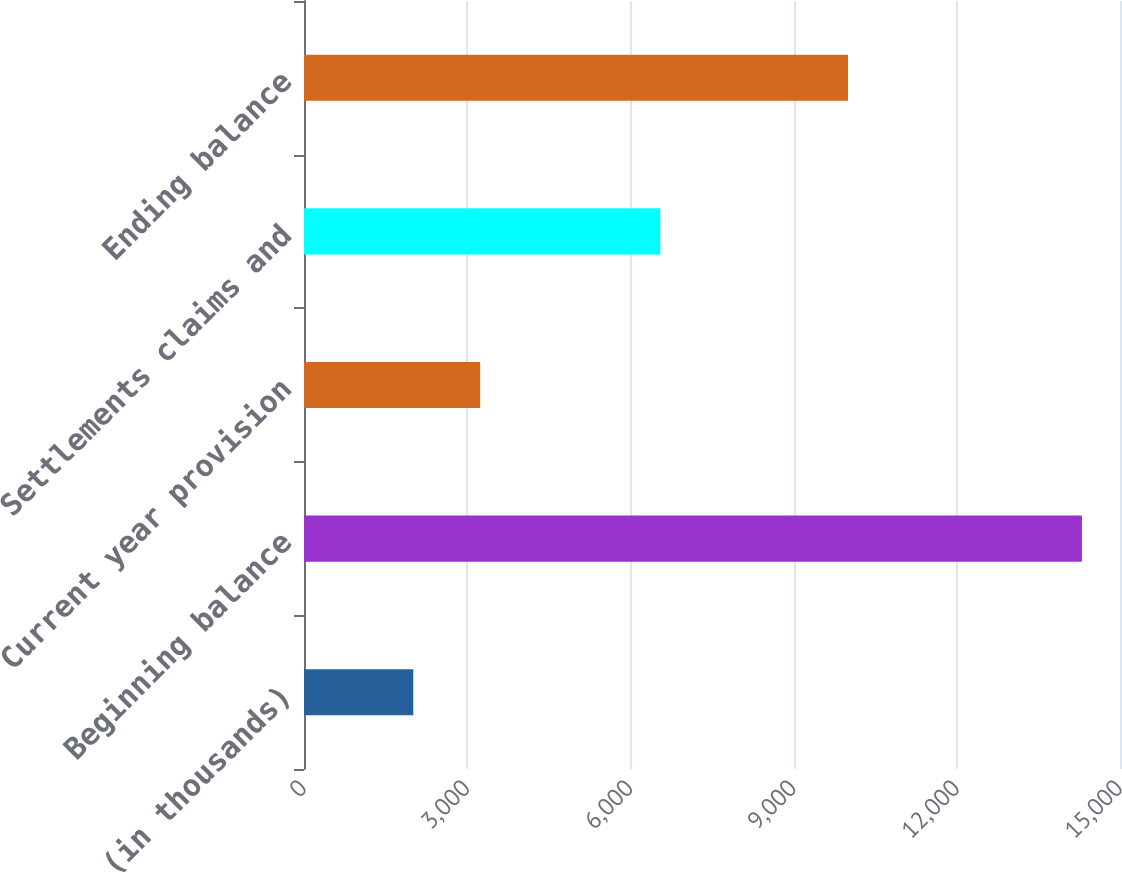<chart> <loc_0><loc_0><loc_500><loc_500><bar_chart><fcel>(in thousands)<fcel>Beginning balance<fcel>Current year provision<fcel>Settlements claims and<fcel>Ending balance<nl><fcel>2009<fcel>14300<fcel>3238.1<fcel>6548<fcel>10000<nl></chart> 